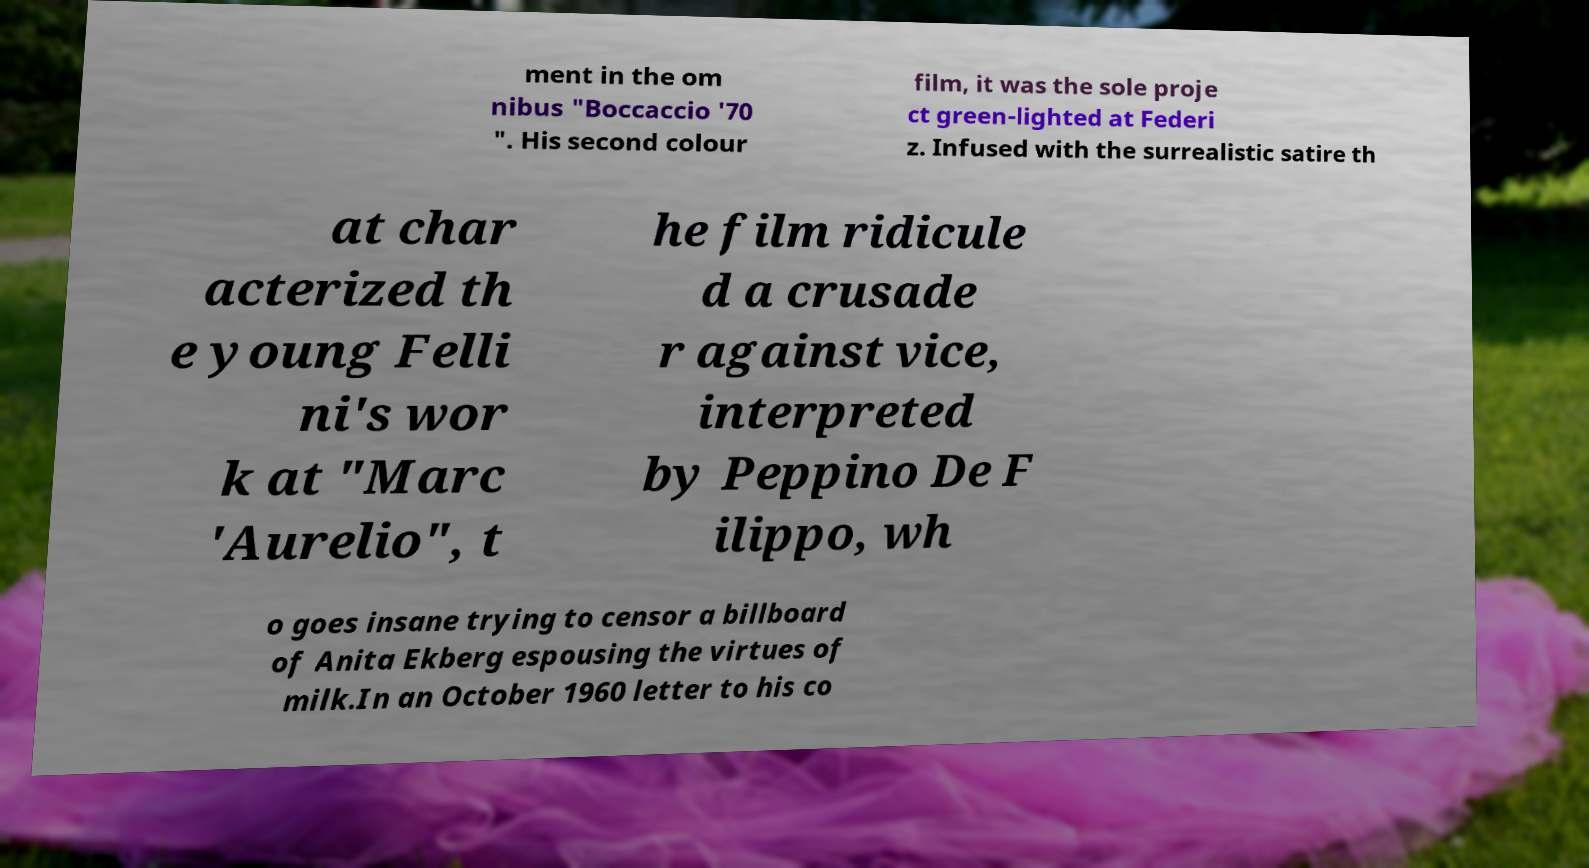Please identify and transcribe the text found in this image. ment in the om nibus "Boccaccio '70 ". His second colour film, it was the sole proje ct green-lighted at Federi z. Infused with the surrealistic satire th at char acterized th e young Felli ni's wor k at "Marc 'Aurelio", t he film ridicule d a crusade r against vice, interpreted by Peppino De F ilippo, wh o goes insane trying to censor a billboard of Anita Ekberg espousing the virtues of milk.In an October 1960 letter to his co 